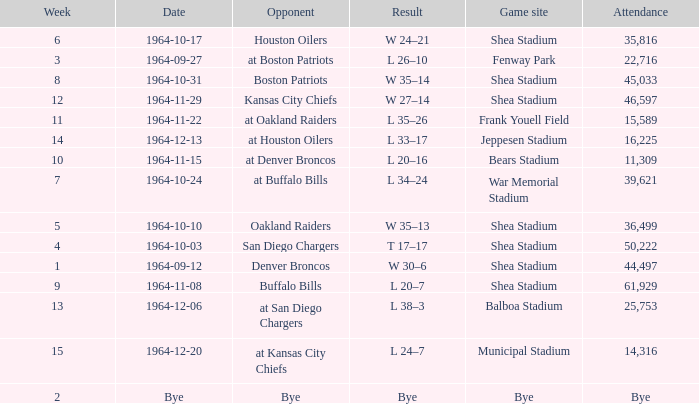Could you parse the entire table as a dict? {'header': ['Week', 'Date', 'Opponent', 'Result', 'Game site', 'Attendance'], 'rows': [['6', '1964-10-17', 'Houston Oilers', 'W 24–21', 'Shea Stadium', '35,816'], ['3', '1964-09-27', 'at Boston Patriots', 'L 26–10', 'Fenway Park', '22,716'], ['8', '1964-10-31', 'Boston Patriots', 'W 35–14', 'Shea Stadium', '45,033'], ['12', '1964-11-29', 'Kansas City Chiefs', 'W 27–14', 'Shea Stadium', '46,597'], ['11', '1964-11-22', 'at Oakland Raiders', 'L 35–26', 'Frank Youell Field', '15,589'], ['14', '1964-12-13', 'at Houston Oilers', 'L 33–17', 'Jeppesen Stadium', '16,225'], ['10', '1964-11-15', 'at Denver Broncos', 'L 20–16', 'Bears Stadium', '11,309'], ['7', '1964-10-24', 'at Buffalo Bills', 'L 34–24', 'War Memorial Stadium', '39,621'], ['5', '1964-10-10', 'Oakland Raiders', 'W 35–13', 'Shea Stadium', '36,499'], ['4', '1964-10-03', 'San Diego Chargers', 'T 17–17', 'Shea Stadium', '50,222'], ['1', '1964-09-12', 'Denver Broncos', 'W 30–6', 'Shea Stadium', '44,497'], ['9', '1964-11-08', 'Buffalo Bills', 'L 20–7', 'Shea Stadium', '61,929'], ['13', '1964-12-06', 'at San Diego Chargers', 'L 38–3', 'Balboa Stadium', '25,753'], ['15', '1964-12-20', 'at Kansas City Chiefs', 'L 24–7', 'Municipal Stadium', '14,316'], ['2', 'Bye', 'Bye', 'Bye', 'Bye', 'Bye']]} What's the Result for week 15? L 24–7. 